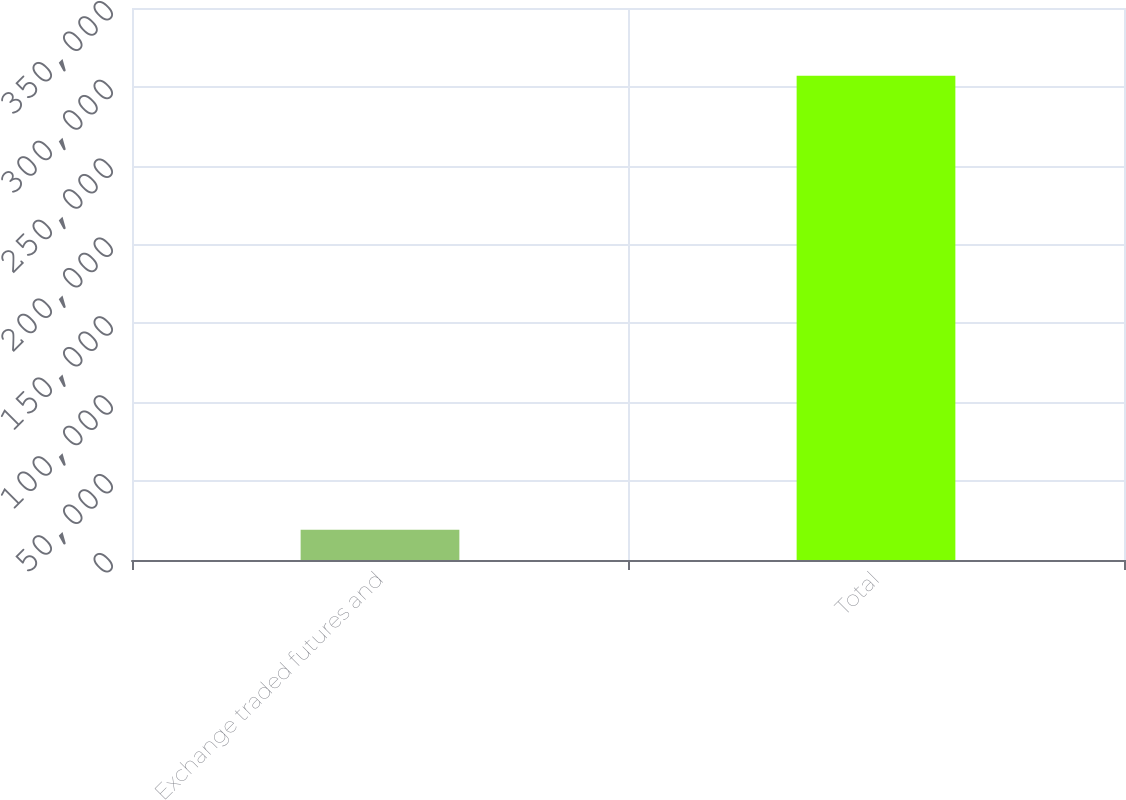Convert chart to OTSL. <chart><loc_0><loc_0><loc_500><loc_500><bar_chart><fcel>Exchange traded futures and<fcel>Total<nl><fcel>19182<fcel>307076<nl></chart> 